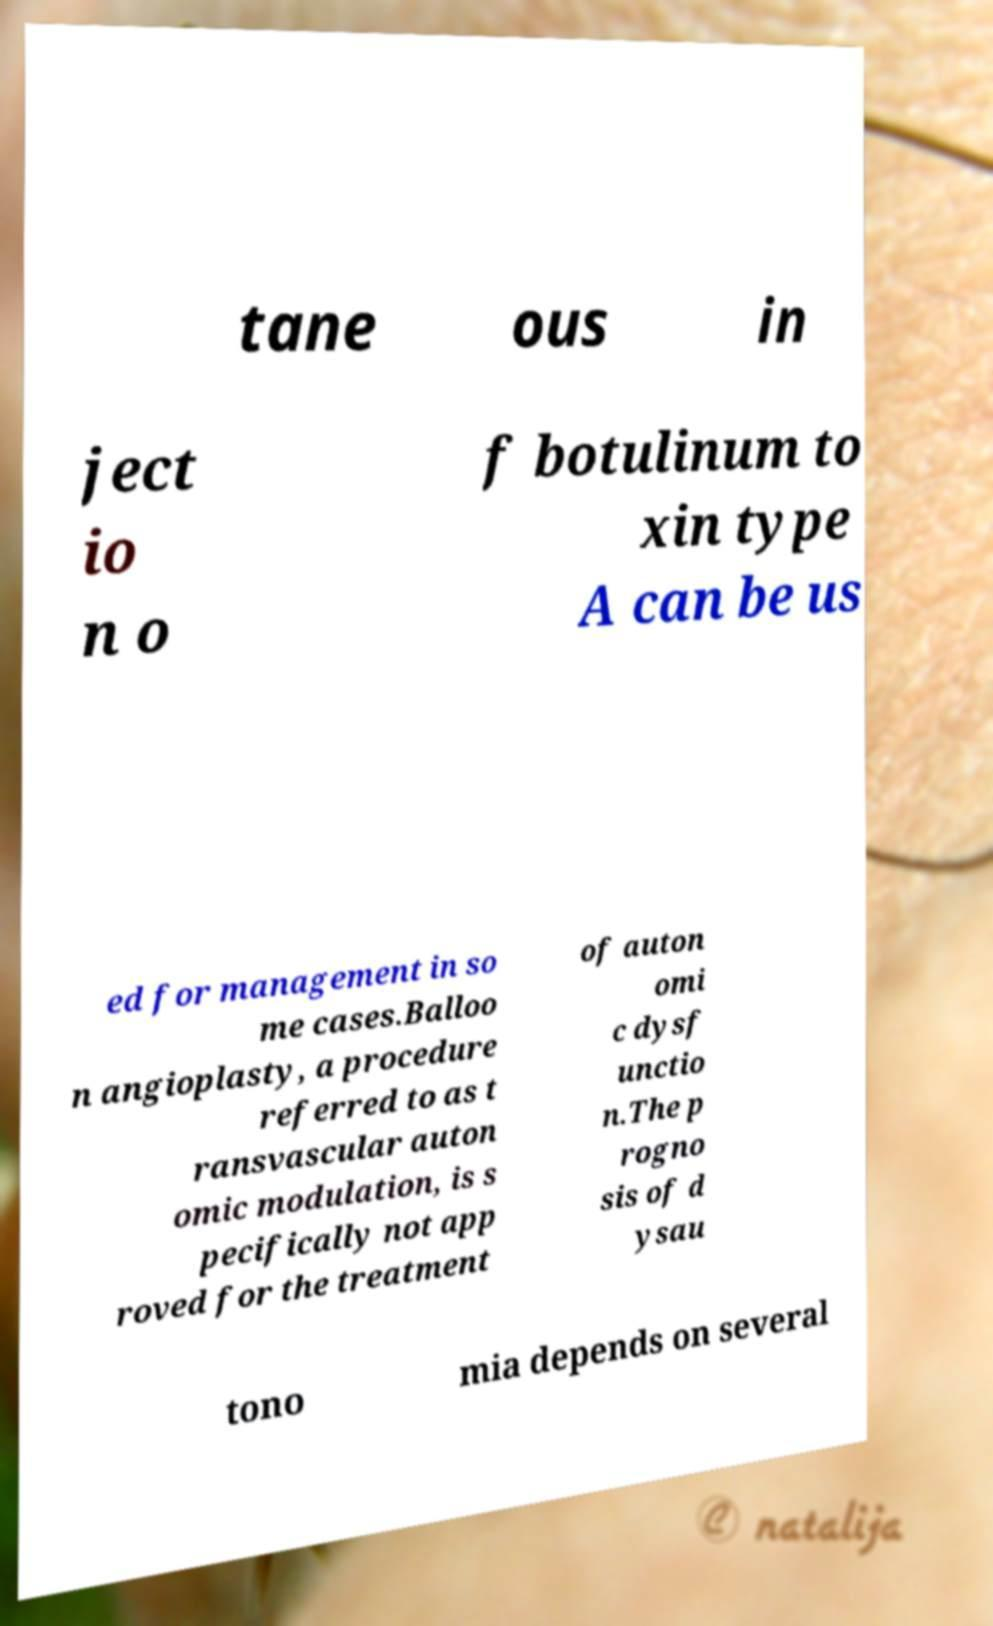Can you read and provide the text displayed in the image?This photo seems to have some interesting text. Can you extract and type it out for me? tane ous in ject io n o f botulinum to xin type A can be us ed for management in so me cases.Balloo n angioplasty, a procedure referred to as t ransvascular auton omic modulation, is s pecifically not app roved for the treatment of auton omi c dysf unctio n.The p rogno sis of d ysau tono mia depends on several 